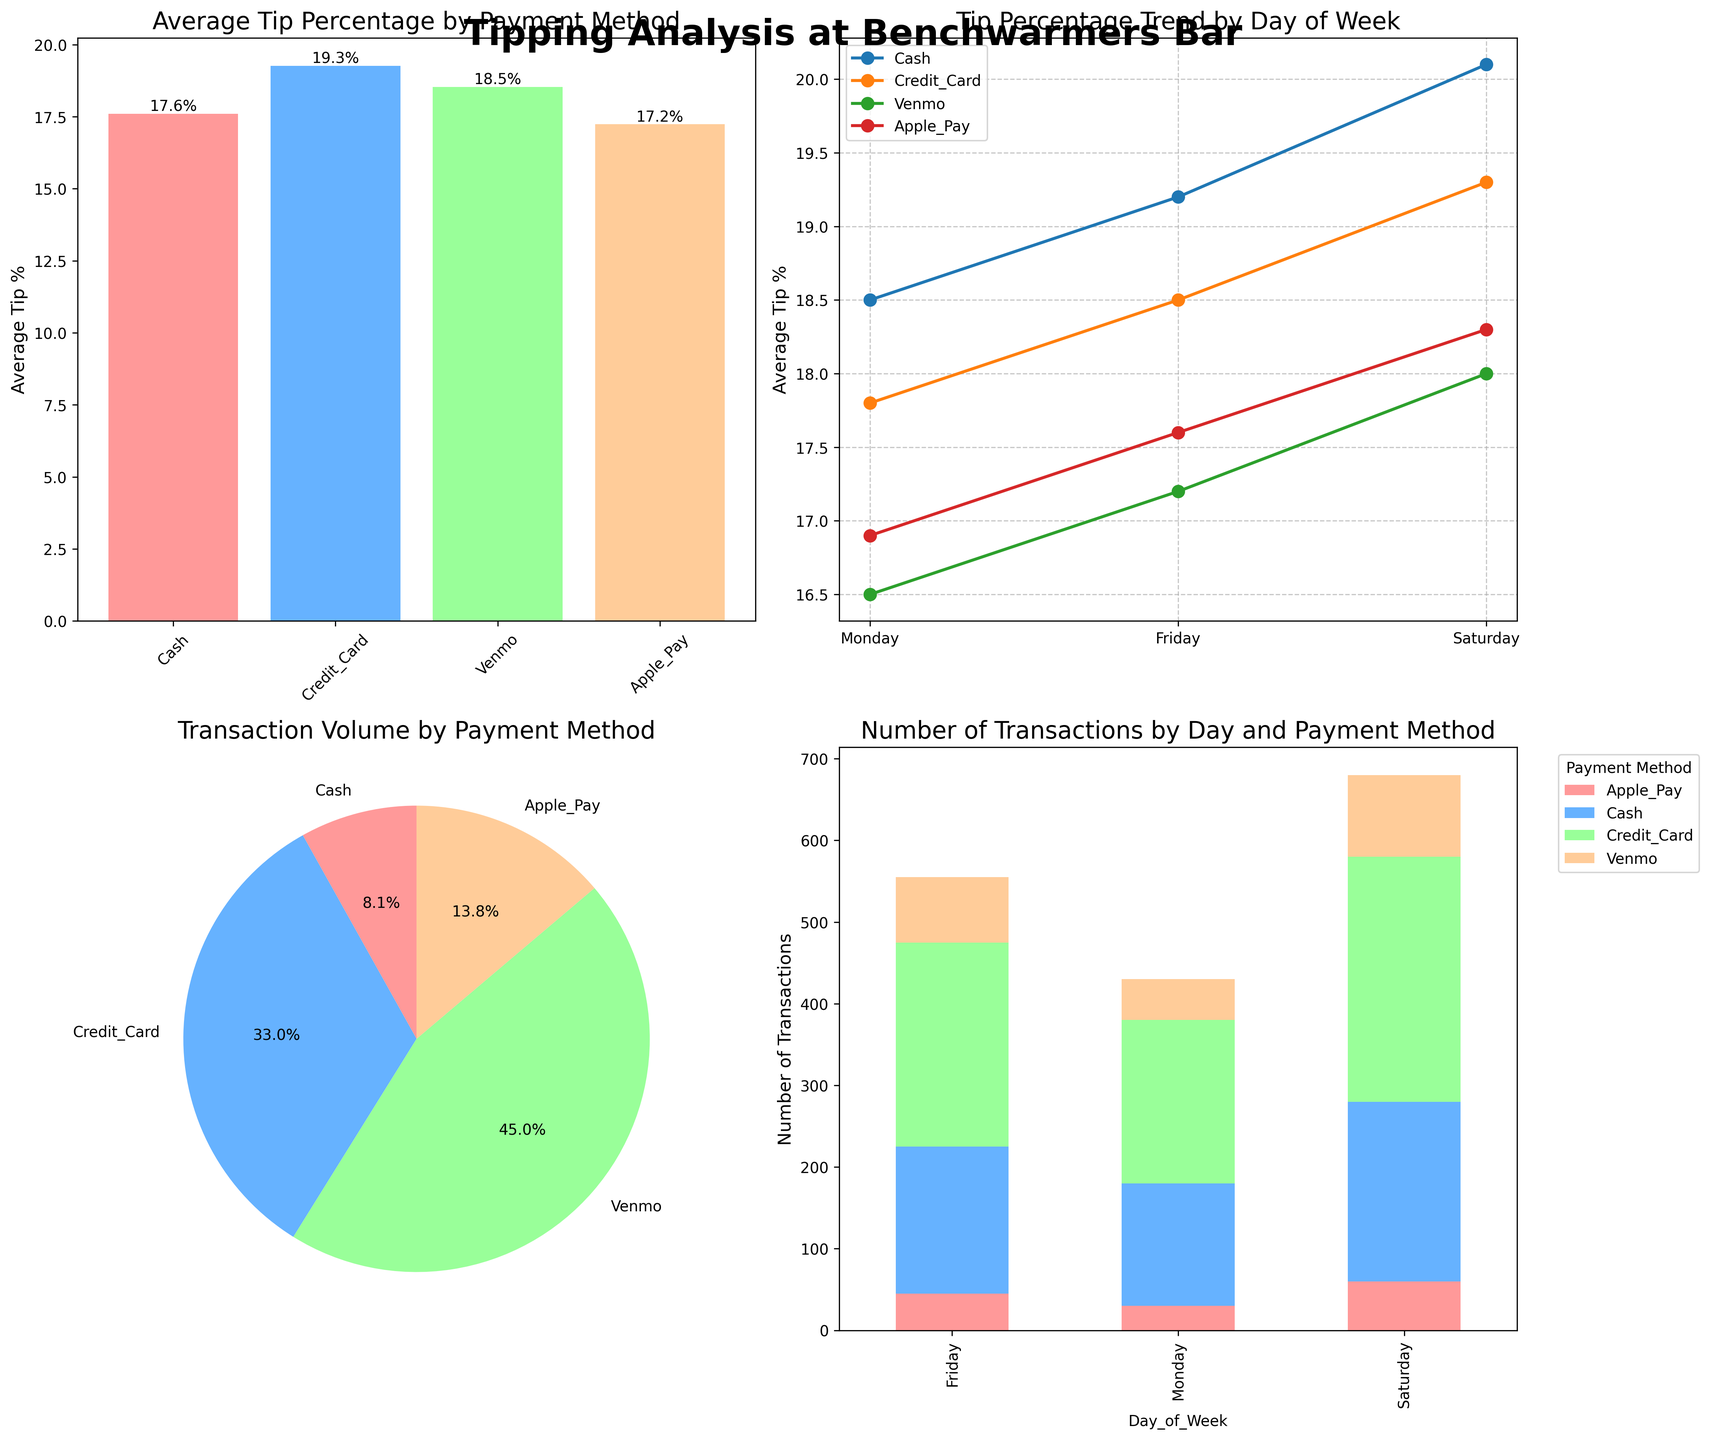What is the average tip percentage for Credit Card? Locate the bar labeled 'Credit Card' in the bar plot. The height of this bar represents the average tip percentage for Credit Card.
Answer: 18.53% Which payment method has the lowest transaction volume? Refer to the pie chart. The smallest segment indicates the payment method with the lowest transaction volume.
Answer: Apple Pay How does the average tip percentage for Cash change from Monday to Friday? Look at the line plot. Find the points for Cash on Monday and Friday and observe the difference in their y-values.
Answer: Increases (from 18.5% to 19.2%) What is the total number of transactions for Venmo throughout the week? Use the stacked bar chart. Sum the number of transactions shown for Venmo across all days of the week.
Answer: 230 transactions Which day of the week has the highest average tip percentage for all payment methods combined? Compare the peaks for each day in the line plot. Identify the overall highest y-value across all days of the week and methods.
Answer: Saturday Between Cash and Credit Card, which has a higher average tip percentage on Saturday? Find the points on the line plot corresponding to Saturday for both Cash and Credit Card. Compare their y-values.
Answer: Cash How does the average tip percentage change for Mobile Apps (Venmo and Apple Pay) from Monday to Friday? Examine the line plot. Find the points for Venmo and Apple Pay on Monday and Friday and calculate the changes.
Answer: Increases for both (Venmo: from 16.5% to 17.2%, Apple Pay: from 16.9% to 17.6%) What percentage of the total transactions were made with Credit Card? Refer to the pie chart. Locate the segment labeled 'Credit Card' and read the percentage value.
Answer: 58.1% On which day did Cash receive the highest average tip percentage? Look at the line plot. Identify the highest point specifically for Cash and note the corresponding day.
Answer: Saturday How many transactions were made on Friday for all payment methods combined? Refer to the stacked bar chart and sum the heights of all bars for Friday.
Answer: 555 transactions 